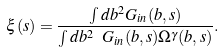Convert formula to latex. <formula><loc_0><loc_0><loc_500><loc_500>\xi ( s ) = \frac { \int d b ^ { 2 } G _ { i n } ( b , s ) } { \int d b ^ { 2 } \ G _ { i n } ( b , s ) \Omega ^ { \gamma } ( b , s ) } .</formula> 